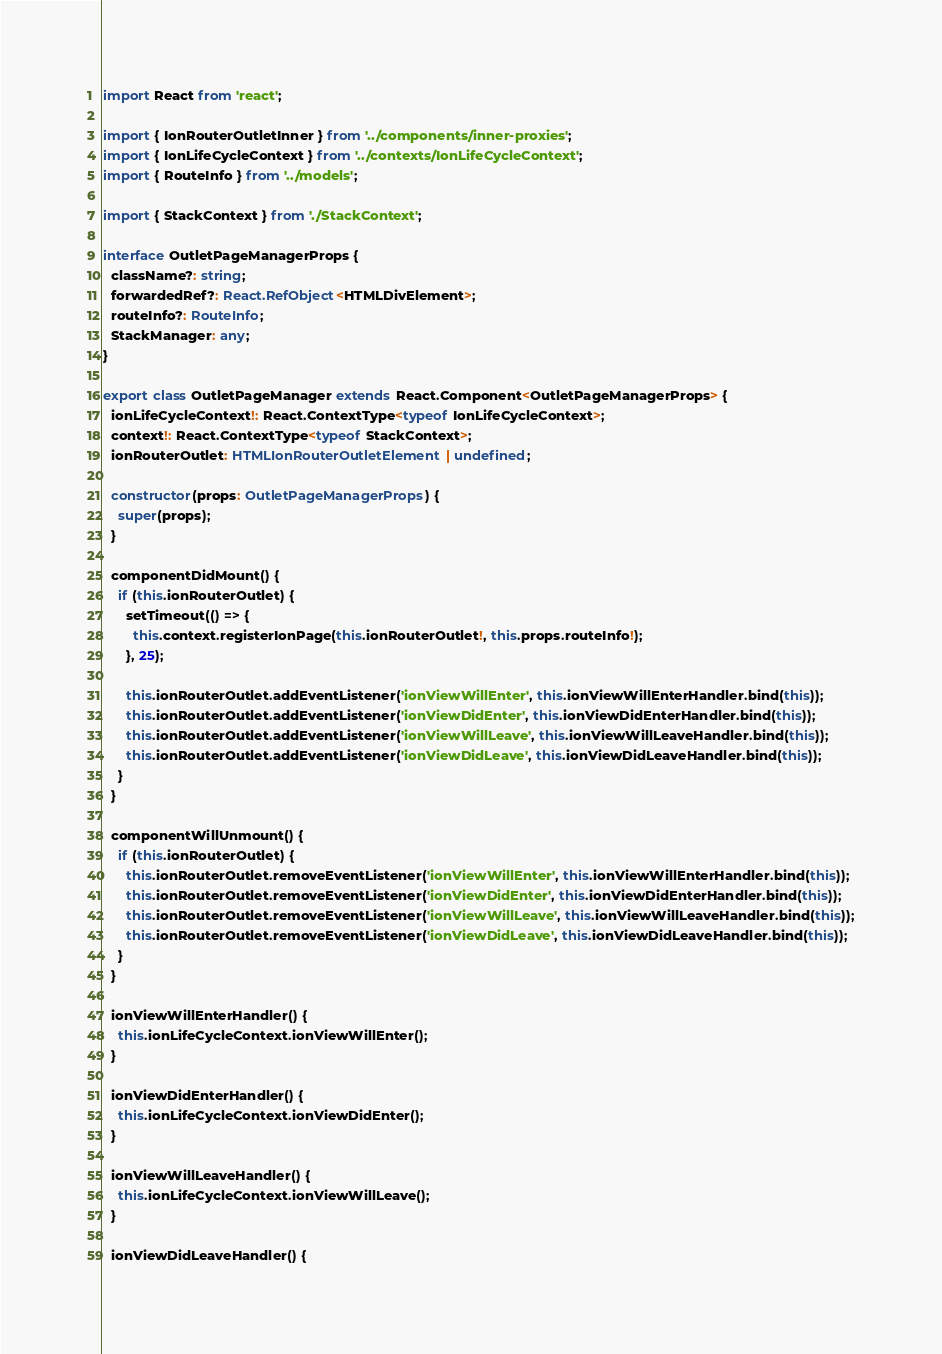<code> <loc_0><loc_0><loc_500><loc_500><_TypeScript_>
import React from 'react';

import { IonRouterOutletInner } from '../components/inner-proxies';
import { IonLifeCycleContext } from '../contexts/IonLifeCycleContext';
import { RouteInfo } from '../models';

import { StackContext } from './StackContext';

interface OutletPageManagerProps {
  className?: string;
  forwardedRef?: React.RefObject<HTMLDivElement>;
  routeInfo?: RouteInfo;
  StackManager: any;
}

export class OutletPageManager extends React.Component<OutletPageManagerProps> {
  ionLifeCycleContext!: React.ContextType<typeof IonLifeCycleContext>;
  context!: React.ContextType<typeof StackContext>;
  ionRouterOutlet: HTMLIonRouterOutletElement | undefined;

  constructor(props: OutletPageManagerProps) {
    super(props);
  }

  componentDidMount() {
    if (this.ionRouterOutlet) {
      setTimeout(() => {
        this.context.registerIonPage(this.ionRouterOutlet!, this.props.routeInfo!);
      }, 25);

      this.ionRouterOutlet.addEventListener('ionViewWillEnter', this.ionViewWillEnterHandler.bind(this));
      this.ionRouterOutlet.addEventListener('ionViewDidEnter', this.ionViewDidEnterHandler.bind(this));
      this.ionRouterOutlet.addEventListener('ionViewWillLeave', this.ionViewWillLeaveHandler.bind(this));
      this.ionRouterOutlet.addEventListener('ionViewDidLeave', this.ionViewDidLeaveHandler.bind(this));
    }
  }

  componentWillUnmount() {
    if (this.ionRouterOutlet) {
      this.ionRouterOutlet.removeEventListener('ionViewWillEnter', this.ionViewWillEnterHandler.bind(this));
      this.ionRouterOutlet.removeEventListener('ionViewDidEnter', this.ionViewDidEnterHandler.bind(this));
      this.ionRouterOutlet.removeEventListener('ionViewWillLeave', this.ionViewWillLeaveHandler.bind(this));
      this.ionRouterOutlet.removeEventListener('ionViewDidLeave', this.ionViewDidLeaveHandler.bind(this));
    }
  }

  ionViewWillEnterHandler() {
    this.ionLifeCycleContext.ionViewWillEnter();
  }

  ionViewDidEnterHandler() {
    this.ionLifeCycleContext.ionViewDidEnter();
  }

  ionViewWillLeaveHandler() {
    this.ionLifeCycleContext.ionViewWillLeave();
  }

  ionViewDidLeaveHandler() {</code> 